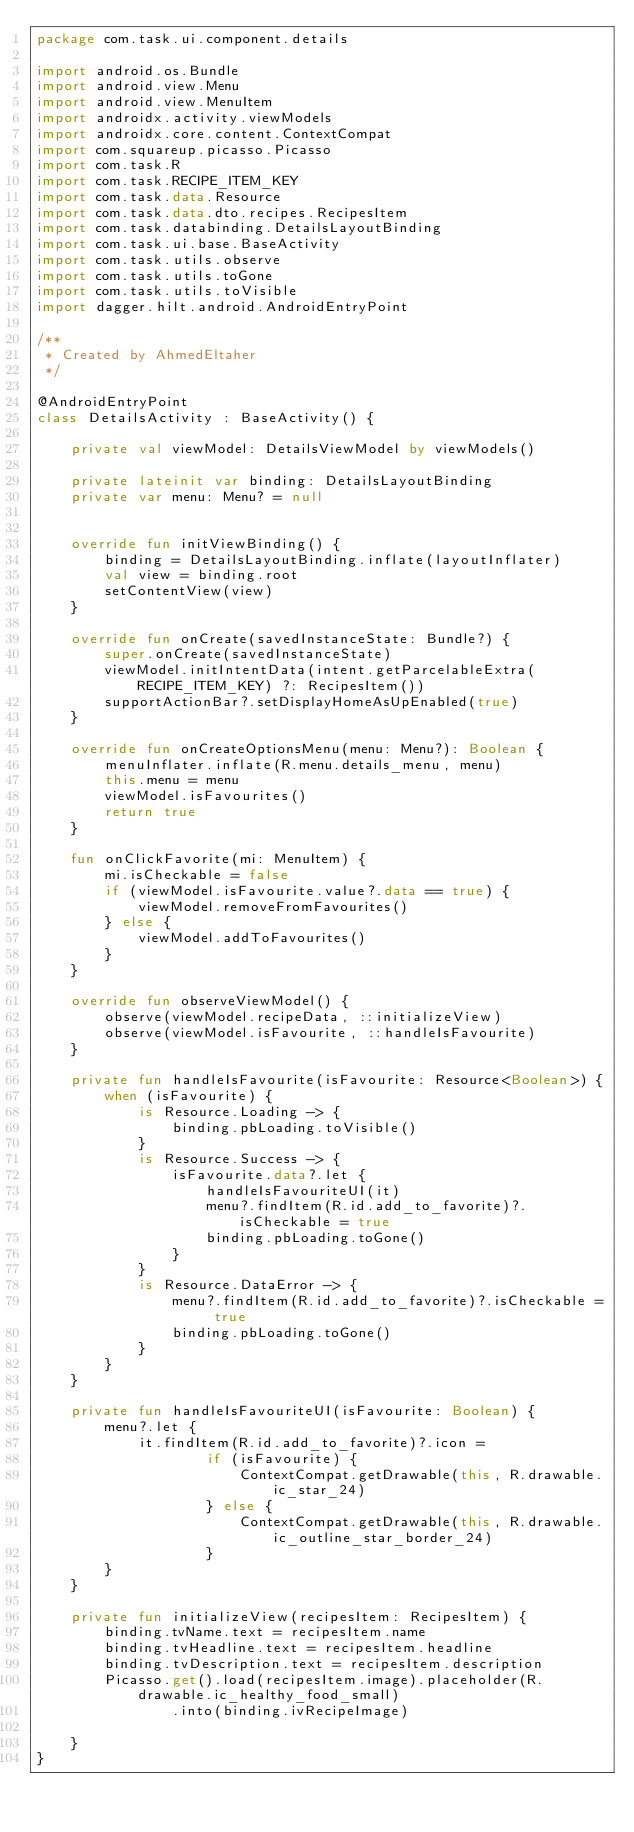<code> <loc_0><loc_0><loc_500><loc_500><_Kotlin_>package com.task.ui.component.details

import android.os.Bundle
import android.view.Menu
import android.view.MenuItem
import androidx.activity.viewModels
import androidx.core.content.ContextCompat
import com.squareup.picasso.Picasso
import com.task.R
import com.task.RECIPE_ITEM_KEY
import com.task.data.Resource
import com.task.data.dto.recipes.RecipesItem
import com.task.databinding.DetailsLayoutBinding
import com.task.ui.base.BaseActivity
import com.task.utils.observe
import com.task.utils.toGone
import com.task.utils.toVisible
import dagger.hilt.android.AndroidEntryPoint

/**
 * Created by AhmedEltaher
 */

@AndroidEntryPoint
class DetailsActivity : BaseActivity() {

    private val viewModel: DetailsViewModel by viewModels()

    private lateinit var binding: DetailsLayoutBinding
    private var menu: Menu? = null


    override fun initViewBinding() {
        binding = DetailsLayoutBinding.inflate(layoutInflater)
        val view = binding.root
        setContentView(view)
    }

    override fun onCreate(savedInstanceState: Bundle?) {
        super.onCreate(savedInstanceState)
        viewModel.initIntentData(intent.getParcelableExtra(RECIPE_ITEM_KEY) ?: RecipesItem())
        supportActionBar?.setDisplayHomeAsUpEnabled(true)
    }

    override fun onCreateOptionsMenu(menu: Menu?): Boolean {
        menuInflater.inflate(R.menu.details_menu, menu)
        this.menu = menu
        viewModel.isFavourites()
        return true
    }

    fun onClickFavorite(mi: MenuItem) {
        mi.isCheckable = false
        if (viewModel.isFavourite.value?.data == true) {
            viewModel.removeFromFavourites()
        } else {
            viewModel.addToFavourites()
        }
    }

    override fun observeViewModel() {
        observe(viewModel.recipeData, ::initializeView)
        observe(viewModel.isFavourite, ::handleIsFavourite)
    }

    private fun handleIsFavourite(isFavourite: Resource<Boolean>) {
        when (isFavourite) {
            is Resource.Loading -> {
                binding.pbLoading.toVisible()
            }
            is Resource.Success -> {
                isFavourite.data?.let {
                    handleIsFavouriteUI(it)
                    menu?.findItem(R.id.add_to_favorite)?.isCheckable = true
                    binding.pbLoading.toGone()
                }
            }
            is Resource.DataError -> {
                menu?.findItem(R.id.add_to_favorite)?.isCheckable = true
                binding.pbLoading.toGone()
            }
        }
    }

    private fun handleIsFavouriteUI(isFavourite: Boolean) {
        menu?.let {
            it.findItem(R.id.add_to_favorite)?.icon =
                    if (isFavourite) {
                        ContextCompat.getDrawable(this, R.drawable.ic_star_24)
                    } else {
                        ContextCompat.getDrawable(this, R.drawable.ic_outline_star_border_24)
                    }
        }
    }

    private fun initializeView(recipesItem: RecipesItem) {
        binding.tvName.text = recipesItem.name
        binding.tvHeadline.text = recipesItem.headline
        binding.tvDescription.text = recipesItem.description
        Picasso.get().load(recipesItem.image).placeholder(R.drawable.ic_healthy_food_small)
                .into(binding.ivRecipeImage)

    }
}
</code> 